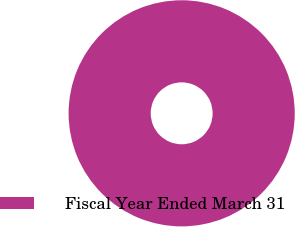<chart> <loc_0><loc_0><loc_500><loc_500><pie_chart><fcel>Fiscal Year Ended March 31<nl><fcel>100.0%<nl></chart> 